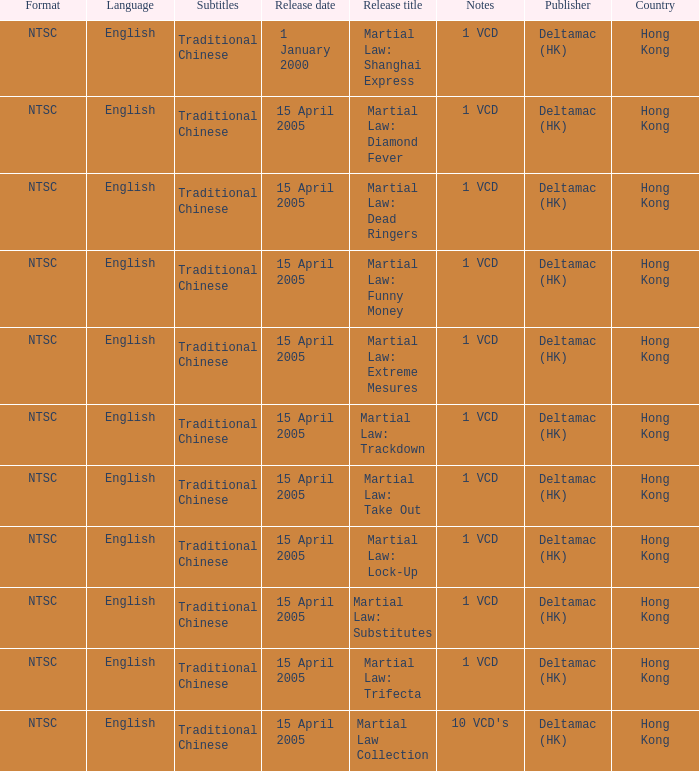What is the release date of Martial Law: Take Out? 15 April 2005. 